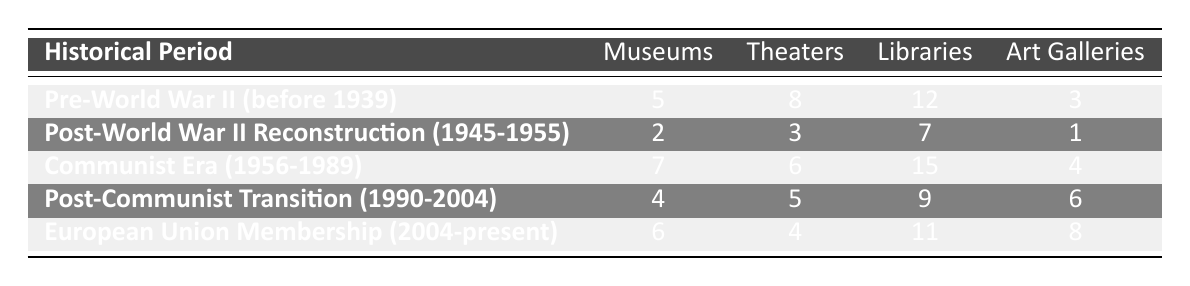What is the total number of libraries established in the Pre-World War II period? According to the table, there are 12 libraries established in the Pre-World War II period before 1939.
Answer: 12 Which period saw the highest number of museums? In the table, the Communist Era (1956-1989) has the highest count of museums with 7 established.
Answer: 7 How many more art galleries were established during the European Union Membership period compared to the Post-World War II Reconstruction period? The European Union Membership period has 8 art galleries while the Post-World War II Reconstruction period has 1. The difference is 8 - 1 = 7 art galleries.
Answer: 7 Is it true that the number of theaters was the lowest during the Post-World War II Reconstruction period? By examining the data, it shows that there were only 3 theaters established during this period, which is lower compared to other periods. Therefore, the statement is true.
Answer: Yes What is the average number of theaters established across all periods? Adding up the number of theaters (8 + 3 + 6 + 5 + 4 = 26) and dividing by the number of periods (5), we get an average of 26/5 = 5.2.
Answer: 5.2 In which historical period did libraries see their peak, and how many were established during that time? The table shows that the highest number of libraries, which is 15, was established during the Communist Era (1956-1989).
Answer: Communist Era, 15 How many museums were established in total during the Post-Communist Transition and European Union Membership periods? In the Post-Communist Transition period, 4 museums were established, and in the European Union Membership period, 6 museums were established. Their total is 4 + 6 = 10 museums.
Answer: 10 museums Were more art galleries established during the Communist Era than the Post-Communist Transition? The Communist Era had 4 art galleries, while the Post-Communist Transition had 6 art galleries. Therefore, the Communist Era had fewer art galleries than the Post-Communist Transition. So the statement is false.
Answer: No 